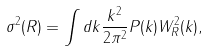Convert formula to latex. <formula><loc_0><loc_0><loc_500><loc_500>\sigma ^ { 2 } ( R ) = \int d k \frac { k ^ { 2 } } { 2 \pi ^ { 2 } } P ( k ) W ^ { 2 } _ { R } ( k ) ,</formula> 